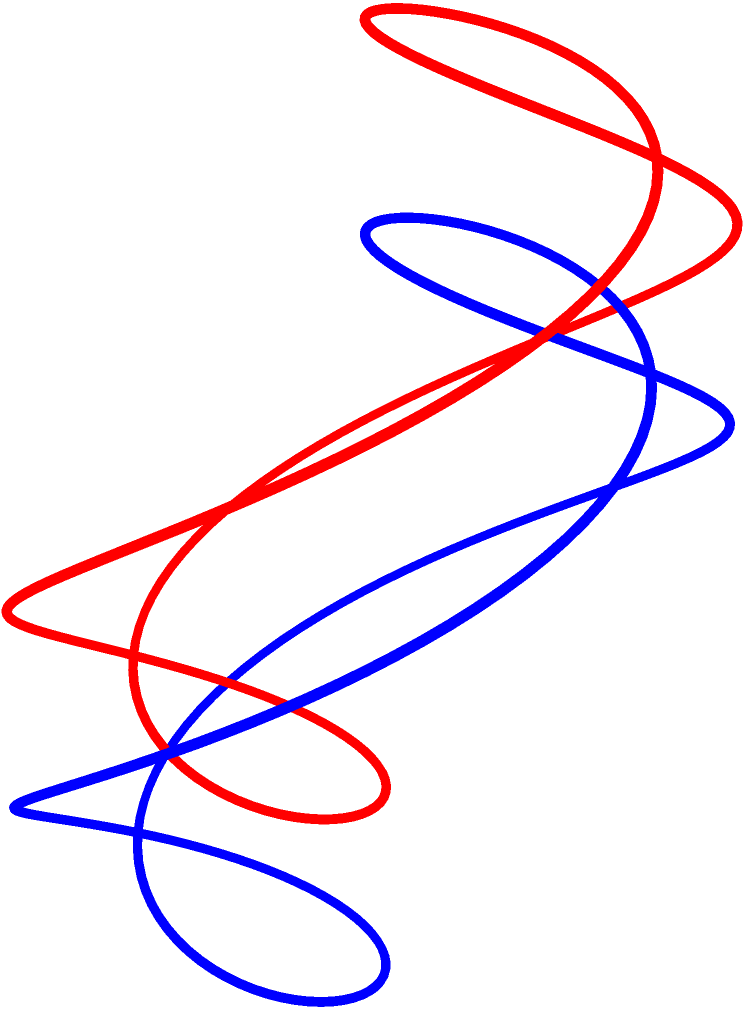Imagine you're creating a Radiohead-themed Möbius strip stage prop for their next tour. If you were to draw a line along the center of this Möbius strip, starting from any point, how many times would you need to go around the strip before returning to your starting point? Explain the topological property that causes this phenomenon. To understand this, let's break it down step-by-step:

1. A Möbius strip is a surface with only one side and one edge. It's created by taking a long rectangle and giving it a half-twist before joining the ends.

2. The key topological property of a Möbius strip is that it's non-orientable. This means that if you were to start walking along the surface, you'd eventually return to your starting point but be upside-down relative to your initial orientation.

3. When drawing a line along the center of a Möbius strip:
   a) You start at a point on one "side" of the strip.
   b) As you move along, you trace the center line.
   c) After one complete revolution around the strip, you find yourself on the "other side" of where you started.
   d) You need to continue for another revolution to return to your exact starting point.

4. This occurs because the half-twist in the Möbius strip effectively doubles the length of the center line compared to the strip's apparent circumference.

5. The mathematical explanation: The Möbius strip has a single continuous surface, but it takes two full revolutions to cover this surface completely when tracing the center line.

This property is related to the strip's Euler characteristic $\chi = 0$ and its non-orientability, which are fundamental topological characteristics of the Möbius strip.
Answer: Twice 